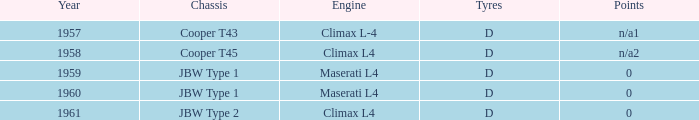Which engine existed in 1961? Climax L4. 